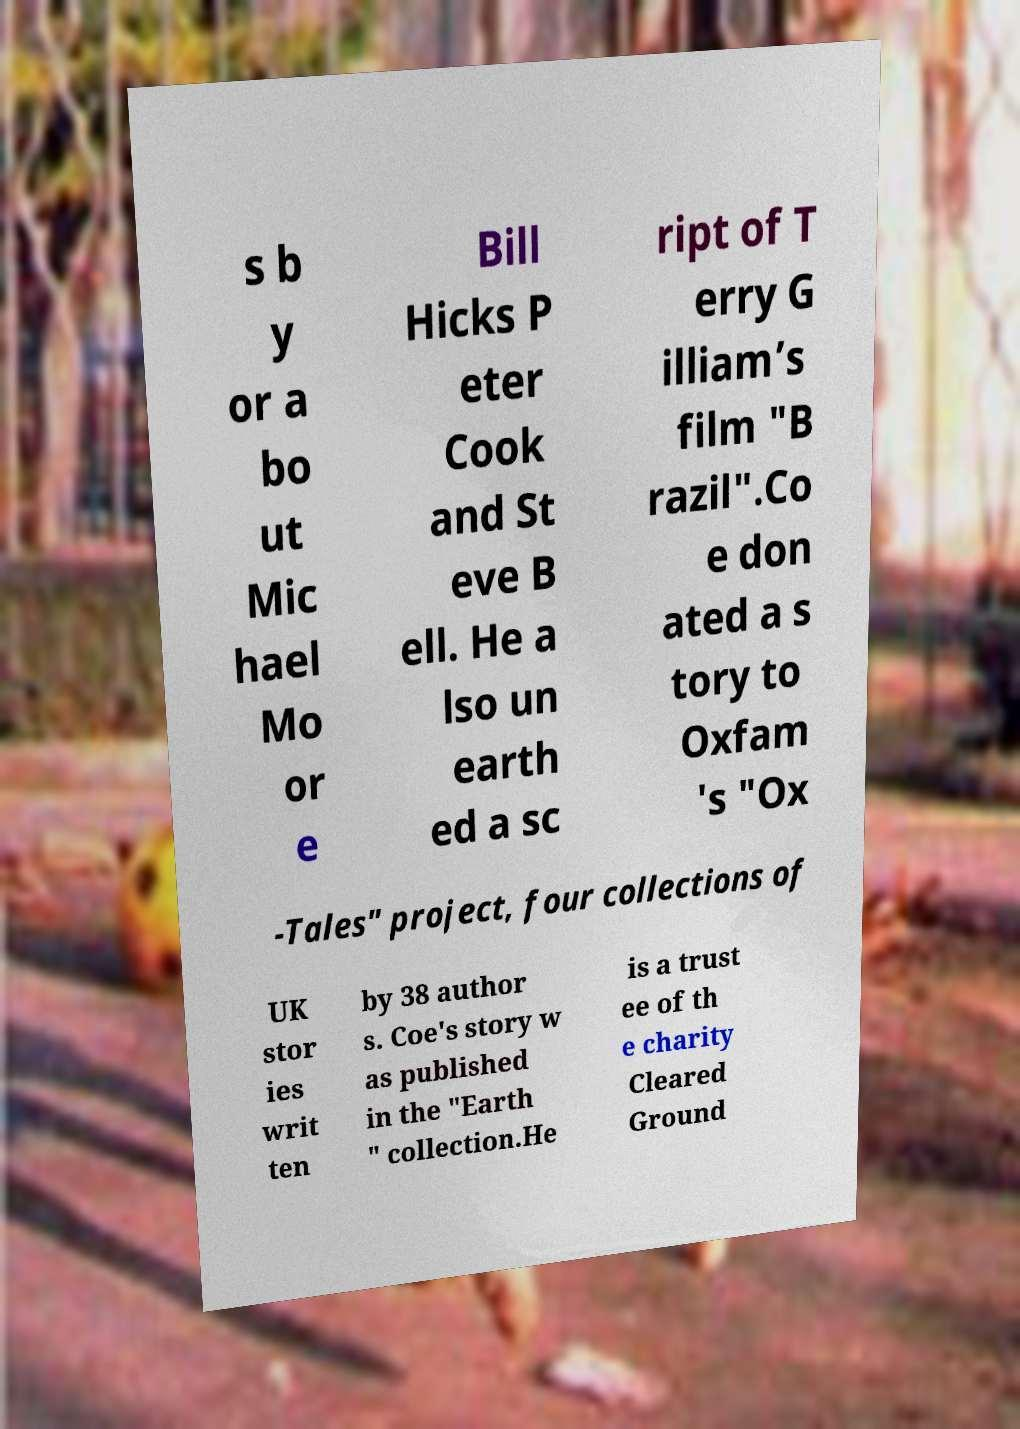Can you read and provide the text displayed in the image?This photo seems to have some interesting text. Can you extract and type it out for me? s b y or a bo ut Mic hael Mo or e Bill Hicks P eter Cook and St eve B ell. He a lso un earth ed a sc ript of T erry G illiam’s film "B razil".Co e don ated a s tory to Oxfam 's "Ox -Tales" project, four collections of UK stor ies writ ten by 38 author s. Coe's story w as published in the "Earth " collection.He is a trust ee of th e charity Cleared Ground 